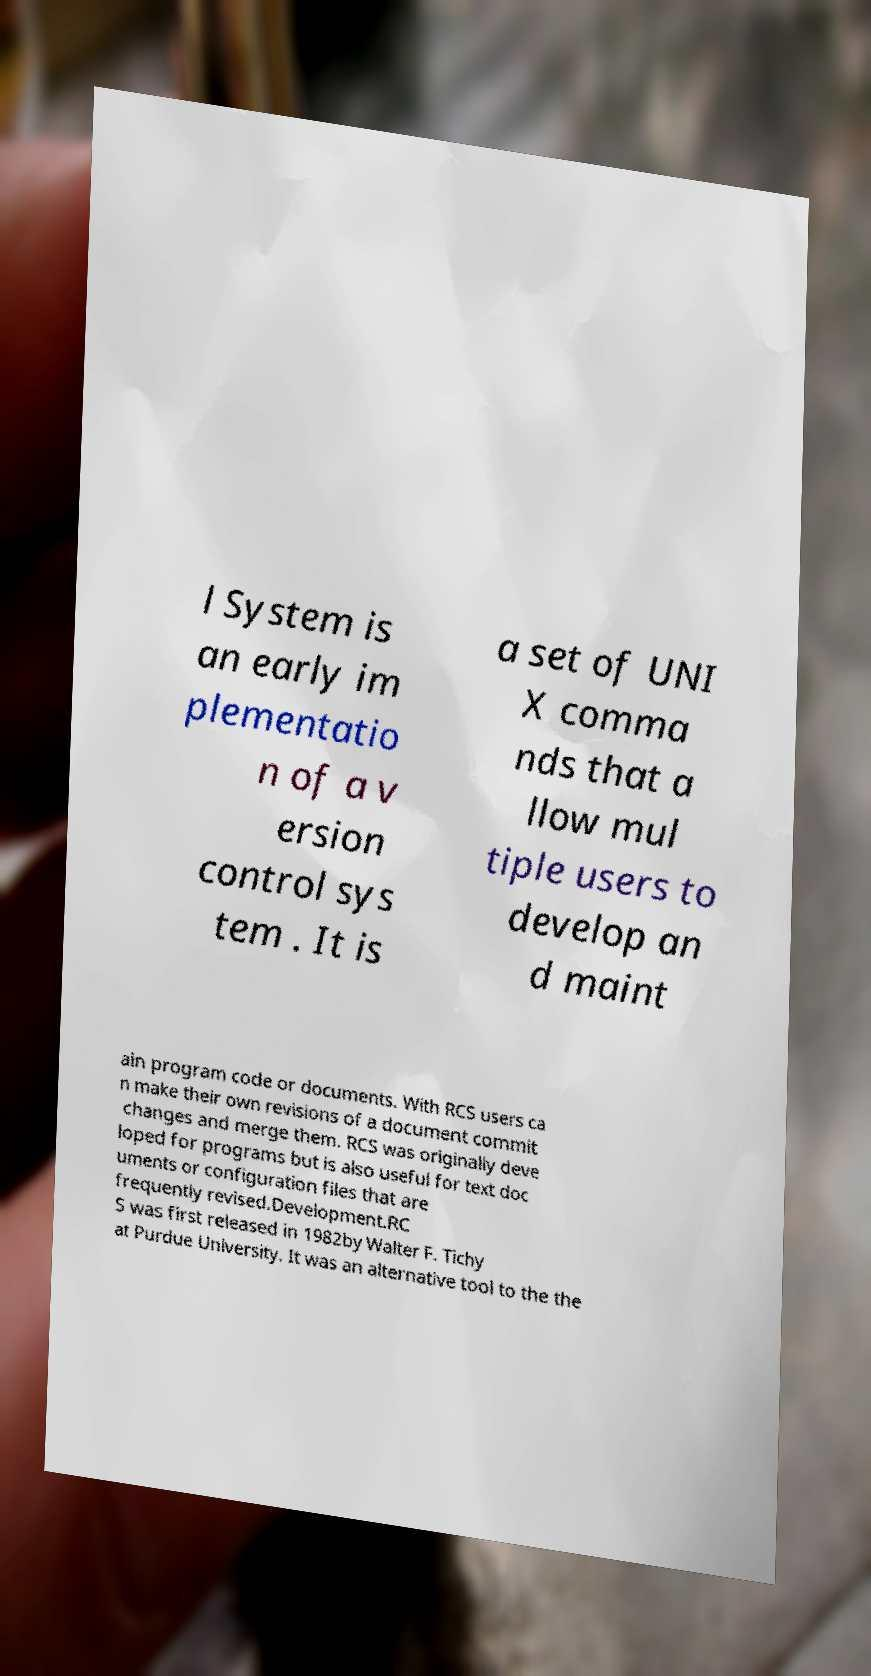I need the written content from this picture converted into text. Can you do that? l System is an early im plementatio n of a v ersion control sys tem . It is a set of UNI X comma nds that a llow mul tiple users to develop an d maint ain program code or documents. With RCS users ca n make their own revisions of a document commit changes and merge them. RCS was originally deve loped for programs but is also useful for text doc uments or configuration files that are frequently revised.Development.RC S was first released in 1982by Walter F. Tichy at Purdue University. It was an alternative tool to the the 